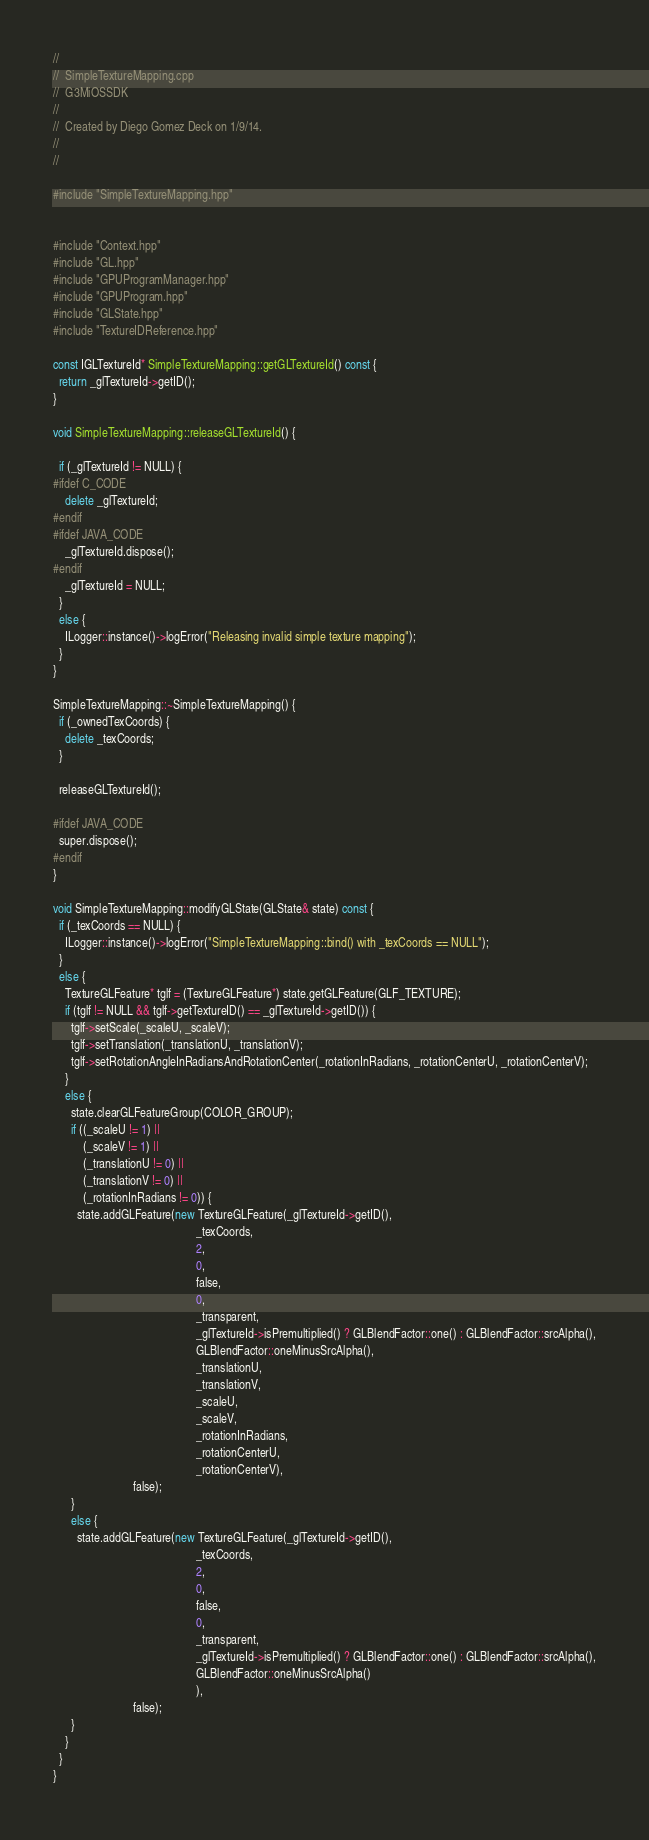<code> <loc_0><loc_0><loc_500><loc_500><_C++_>//
//  SimpleTextureMapping.cpp
//  G3MiOSSDK
//
//  Created by Diego Gomez Deck on 1/9/14.
//
//

#include "SimpleTextureMapping.hpp"


#include "Context.hpp"
#include "GL.hpp"
#include "GPUProgramManager.hpp"
#include "GPUProgram.hpp"
#include "GLState.hpp"
#include "TextureIDReference.hpp"

const IGLTextureId* SimpleTextureMapping::getGLTextureId() const {
  return _glTextureId->getID();
}

void SimpleTextureMapping::releaseGLTextureId() {

  if (_glTextureId != NULL) {
#ifdef C_CODE
    delete _glTextureId;
#endif
#ifdef JAVA_CODE
    _glTextureId.dispose();
#endif
    _glTextureId = NULL;
  }
  else {
    ILogger::instance()->logError("Releasing invalid simple texture mapping");
  }
}

SimpleTextureMapping::~SimpleTextureMapping() {
  if (_ownedTexCoords) {
    delete _texCoords;
  }

  releaseGLTextureId();

#ifdef JAVA_CODE
  super.dispose();
#endif
}

void SimpleTextureMapping::modifyGLState(GLState& state) const {
  if (_texCoords == NULL) {
    ILogger::instance()->logError("SimpleTextureMapping::bind() with _texCoords == NULL");
  }
  else {
    TextureGLFeature* tglf = (TextureGLFeature*) state.getGLFeature(GLF_TEXTURE);
    if (tglf != NULL && tglf->getTextureID() == _glTextureId->getID()) {
      tglf->setScale(_scaleU, _scaleV);
      tglf->setTranslation(_translationU, _translationV);
      tglf->setRotationAngleInRadiansAndRotationCenter(_rotationInRadians, _rotationCenterU, _rotationCenterV);
    }
    else {
      state.clearGLFeatureGroup(COLOR_GROUP);
      if ((_scaleU != 1) ||
          (_scaleV != 1) ||
          (_translationU != 0) ||
          (_translationV != 0) ||
          (_rotationInRadians != 0)) {
        state.addGLFeature(new TextureGLFeature(_glTextureId->getID(),
                                                _texCoords,
                                                2,
                                                0,
                                                false,
                                                0,
                                                _transparent,
                                                _glTextureId->isPremultiplied() ? GLBlendFactor::one() : GLBlendFactor::srcAlpha(),
                                                GLBlendFactor::oneMinusSrcAlpha(),
                                                _translationU,
                                                _translationV,
                                                _scaleU,
                                                _scaleV,
                                                _rotationInRadians,
                                                _rotationCenterU,
                                                _rotationCenterV),
                           false);
      }
      else {
        state.addGLFeature(new TextureGLFeature(_glTextureId->getID(),
                                                _texCoords,
                                                2,
                                                0,
                                                false,
                                                0,
                                                _transparent,
                                                _glTextureId->isPremultiplied() ? GLBlendFactor::one() : GLBlendFactor::srcAlpha(),
                                                GLBlendFactor::oneMinusSrcAlpha()
                                                ),
                           false);
      }
    }
  }
}
</code> 